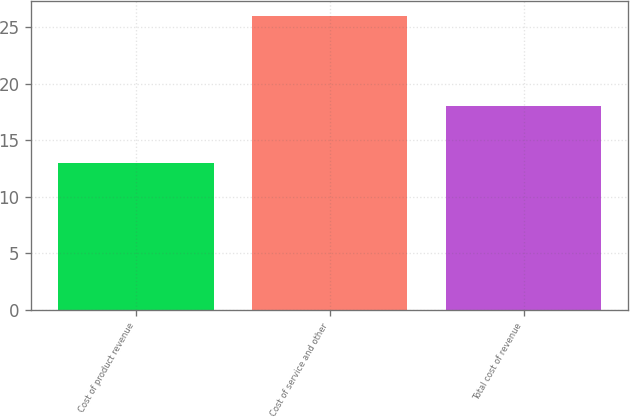Convert chart. <chart><loc_0><loc_0><loc_500><loc_500><bar_chart><fcel>Cost of product revenue<fcel>Cost of service and other<fcel>Total cost of revenue<nl><fcel>13<fcel>26<fcel>18<nl></chart> 